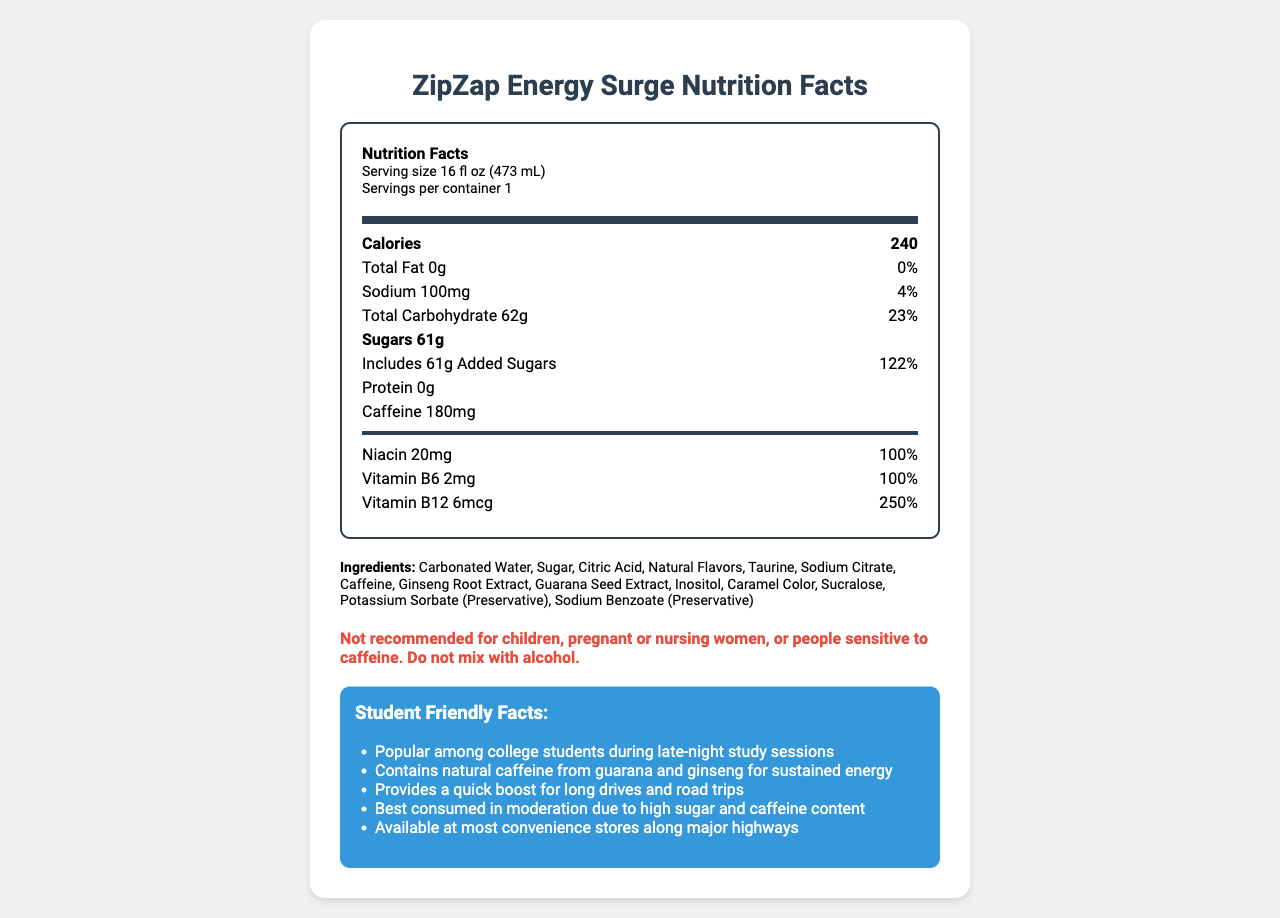what is the serving size of ZipZap Energy Surge? The serving size is explicitly stated at the beginning of the nutrition facts label: "Serving size 16 fl oz (473 mL)".
Answer: 16 fl oz (473 mL) how much caffeine is in one serving of ZipZap Energy Surge? The amount of caffeine is listed under the nutrition facts as "Caffeine 180mg".
Answer: 180mg what is the daily value percentage of Vitamin B12 in ZipZap Energy Surge? Under the vitamins and minerals section, Vitamin B12 is shown as providing 250% of the daily value.
Answer: 250% how many total carbohydrates are there in one serving? The label states that the "Total Carbohydrate" content is 62g.
Answer: 62g what is the main caution mentioned about consuming ZipZap Energy Surge? The caution is highlighted under the consumer warning section: "Not recommended for children, pregnant or nursing women, or people sensitive to caffeine. Do not mix with alcohol."
Answer: Not recommended for children, pregnant or nursing women, or people sensitive to caffeine. Do not mix with alcohol. which vitamin is present at the highest daily value percentage in ZipZap Energy Surge? Vitamin B12 is listed with a daily value of 250%, which is higher than the other vitamins listed.
Answer: Vitamin B12 where is ZipZap Energy Surge distributed from? The distributor's location is stated at the bottom as "ZipZap Beverages, Inc., Los Angeles, CA 90001".
Answer: Los Angeles, CA 90001 what are the allergens mentioned on the label? The allergen information states that the product is "Manufactured in a facility that also processes milk, soy, and wheat products."
Answer: Milk, soy, and wheat products how much sodium is in a serving? A. 50mg B. 80mg C. 100mg D. 150mg The sodium content is listed as "Sodium 100mg" on the label.
Answer: C. 100mg which of the following is not an ingredient in ZipZap Energy Surge? A. Taurine B. Glucose C. Citric Acid The list of ingredients includes Taurine and Citric Acid but not Glucose.
Answer: B. Glucose is ZipZap Energy Surge suitable for children? The consumer warning clearly states "Not recommended for children."
Answer: No summarize the main purpose of the document. The document aims to inform consumers about the nutritional value and safety of the energy drink, emphasizing its benefits and cautionary advice.
Answer: The document is a nutrition facts label for ZipZap Energy Surge, providing detailed nutritional information, ingredient list, and consumer warnings. It highlights the product's content, including calories, vitamins, and specific cautionary advice for certain consumers. Additionally, it mentions student-friendly facts that appeal particularly to college students. how many grams of protein does ZipZap Energy Surge contain? The label states that the protein content is "0g".
Answer: 0g what are some key benefits of ZipZap Energy Surge for students? These are listed under the "Student Friendly Facts" section.
Answer: Popular among college students during late-night study sessions, contains natural caffeine from guarana and ginseng for sustained energy, provides a quick boost for long drives and road trips, best consumed in moderation due to high sugar and caffeine content, available at most convenience stores along major highways what percentage of daily value does total carbohydrate in ZipZap Energy Surge provide? The daily value percentage for total carbohydrate is given as "23%".
Answer: 23% which ingredient is a preservative? The ingredients list includes "Potassium Sorbate (Preservative)" and "Sodium Benzoate (Preservative)".
Answer: Potassium Sorbate and Sodium Benzoate how much sugar is added to ZipZap Energy Surge? The label notes "Includes 61g Added Sugars" under the sugars section.
Answer: 61g what's the primary function of the document? The document's primary function is not explicitly stated. We can infer that it's to provide nutritional information about the product, but this isn't directly labeled.
Answer: Cannot be determined what is the manufacturing facility's primary function? The document does not provide explicit details about the primary function of the manufacturing facility beyond processing milk, soy, and wheat products.
Answer: Not enough information 